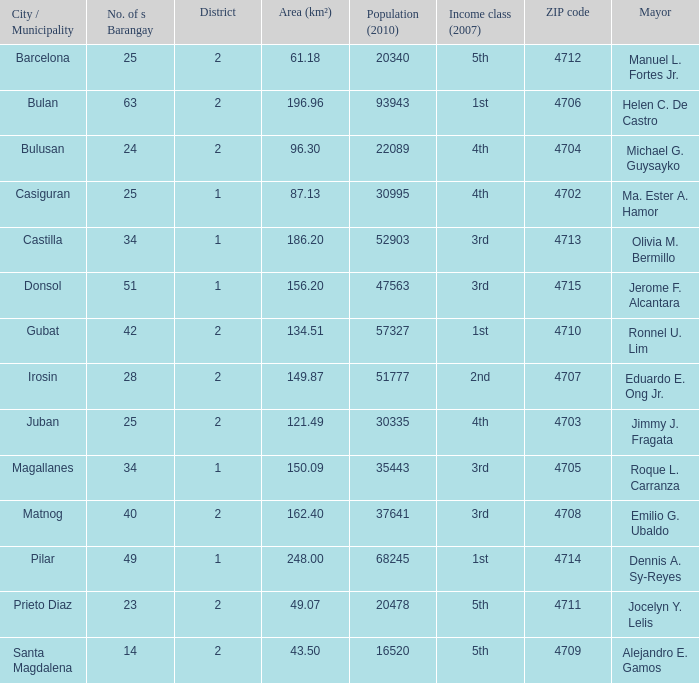During ma. ester a. hamor's term as mayor, what were the overall financial gains for elegance (2007)? 4th. 